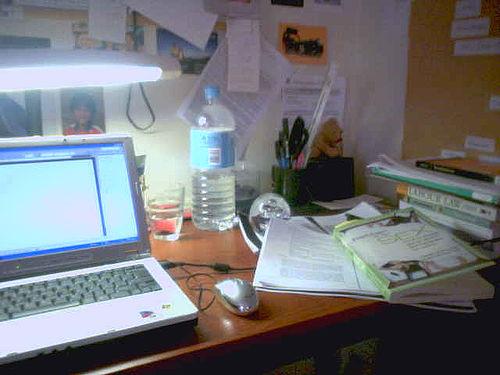What is next to the laptop?
Write a very short answer. Mouse. How many computers are on?
Concise answer only. 1. What kind of beverage does the bottle hold?
Give a very brief answer. Water. What is the shiny blue object above the computer screen from?
Be succinct. Light. What is in the bottle?
Quick response, please. Water. What color is the mouse?
Be succinct. Silver. Is the laptop on?
Give a very brief answer. Yes. How many pens are in the picture?
Concise answer only. 2. What is the item called that is plugged into the side of the laptop?
Concise answer only. Mouse. 